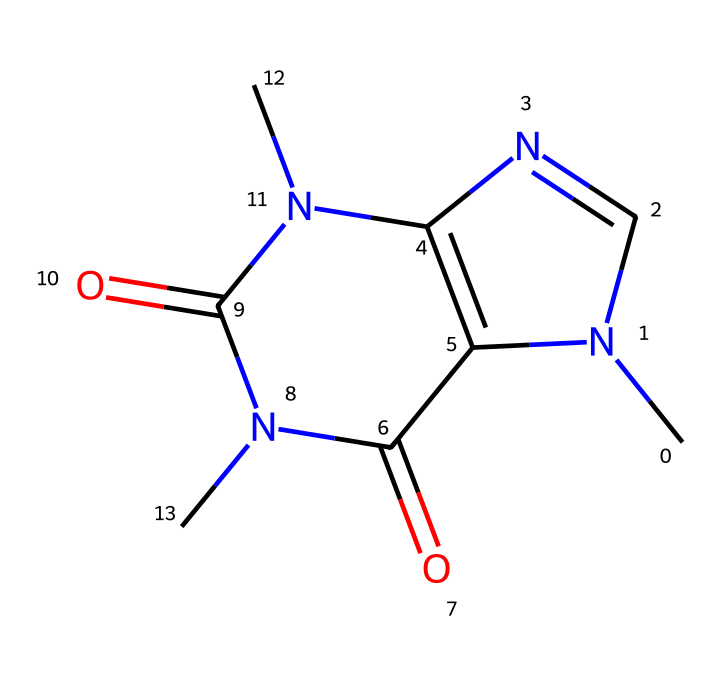What is the molecular formula of this compound? To determine the molecular formula, count the atoms of each element in the structure based on the SMILES representation. The structure indicates there are 8 carbon atoms (C), 10 hydrogen atoms (H), and 4 nitrogen atoms (N) present. Therefore, the molecular formula is C8H10N4O2.
Answer: C8H10N4O2 How many nitrogen atoms are present in caffeine? By analyzing the SMILES structure, we note that there are four nitrogen atoms indicated in the arrangement. Therefore, the total count is 4 nitrogen atoms.
Answer: 4 What type of molecule is caffeine classified as? Caffeine is categorized as an alkaloid, which refers to nitrogen-containing organic compounds with significant pharmacological effects. This classification can be deduced by observing the presence of multiple nitrogen atoms in its structure.
Answer: alkaloid What is the number of rings in the caffeine structure? Reviewing the SMILES notation, we can identify that there are three rings present in the molecular structure, indicative of its complex cyclic arrangement.
Answer: 3 Does caffeine have any oxygen atoms? Upon examining the structure from the SMILES representation, we find that there are two carbonyl functional groups (C=O) represented, confirming the presence of two oxygen atoms in the compound.
Answer: 2 What effect does caffeine primarily have on the human body? Caffeine primarily acts as a stimulant on the central nervous system, enhancing alertness and reducing fatigue. This is a common pharmacological property attributed to many alkaloids, including caffeine specifically.
Answer: stimulant 